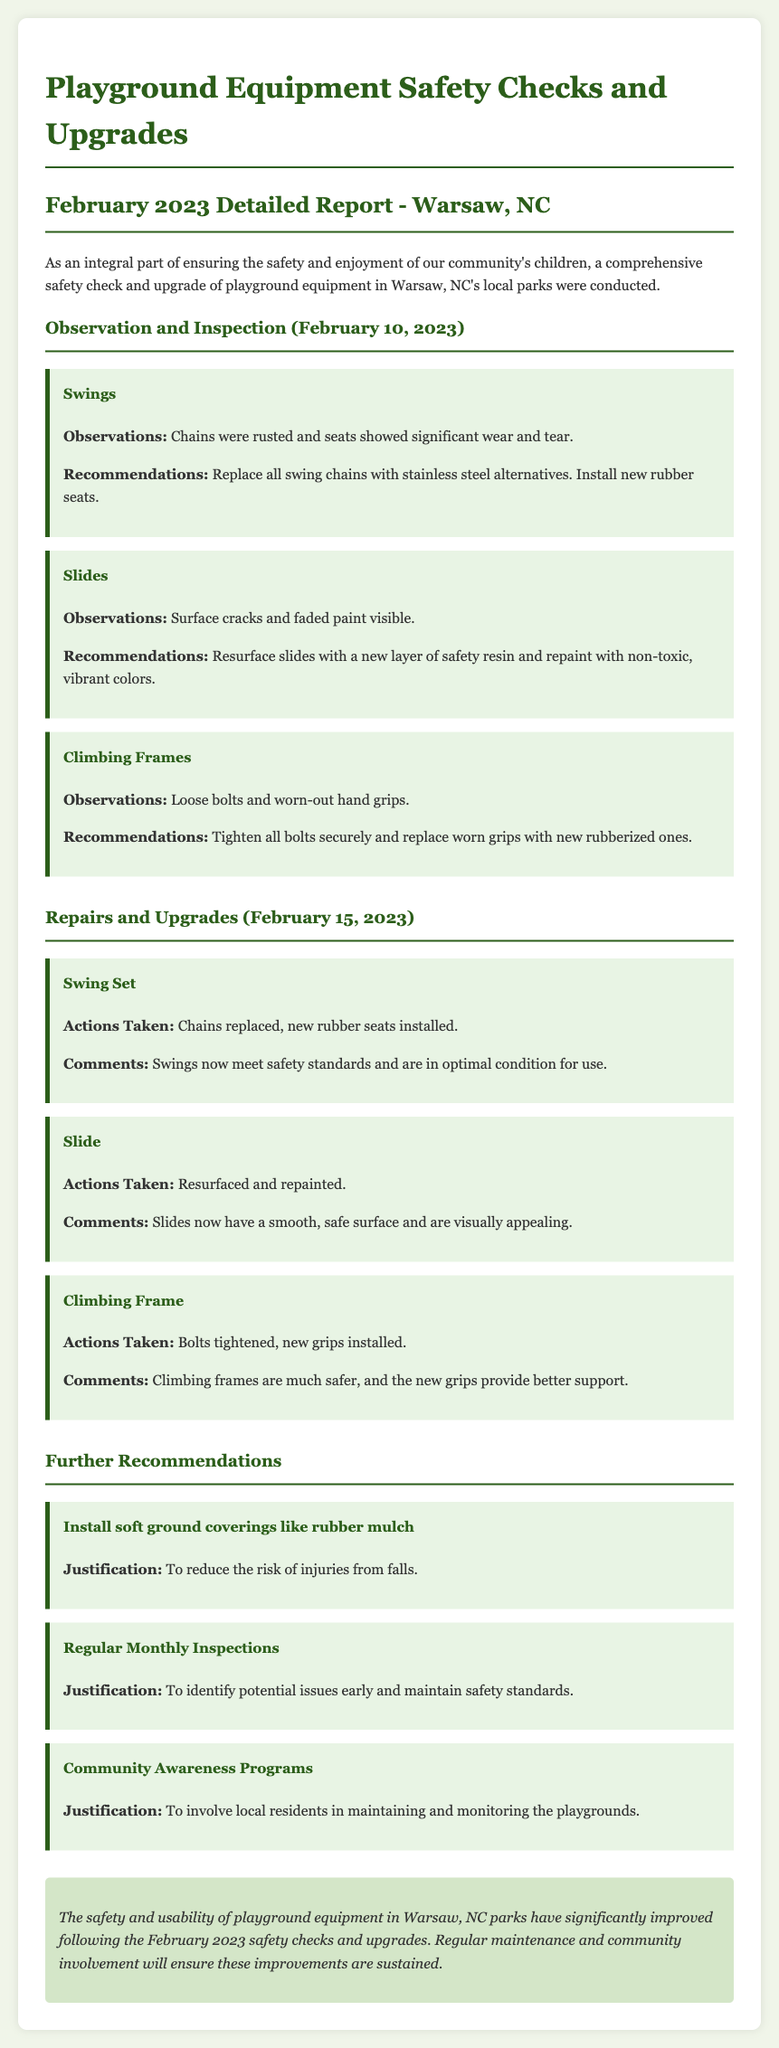What date did the observations take place? The observations were made on February 10, 2023, as mentioned in the report.
Answer: February 10, 2023 What was the recommendation for the swings? The recommendation for the swings was to replace all swing chains with stainless steel alternatives and install new rubber seats.
Answer: Replace chains and install new seats How many areas were inspected in the report? There are three areas inspected in the report: swings, slides, and climbing frames.
Answer: Three areas What actions were taken for the slides? The report states that the slides were resurfaced and repainted.
Answer: Resurfaced and repainted What improvement is suggested for reducing injury risks? The document suggests installing soft ground coverings like rubber mulch to reduce the risk of injuries from falls.
Answer: Install rubber mulch What types of additional programs are recommended for community involvement? The report mentions community awareness programs as a recommendation for local residents' involvement.
Answer: Community awareness programs What were the comments regarding the climbing frames after repairs? The comments noted that climbing frames are much safer, and the new grips provide better support.
Answer: Much safer with better support What is the conclusion about the overall safety checks? The conclusion mentions that the safety and usability of playground equipment have significantly improved.
Answer: Significantly improved 